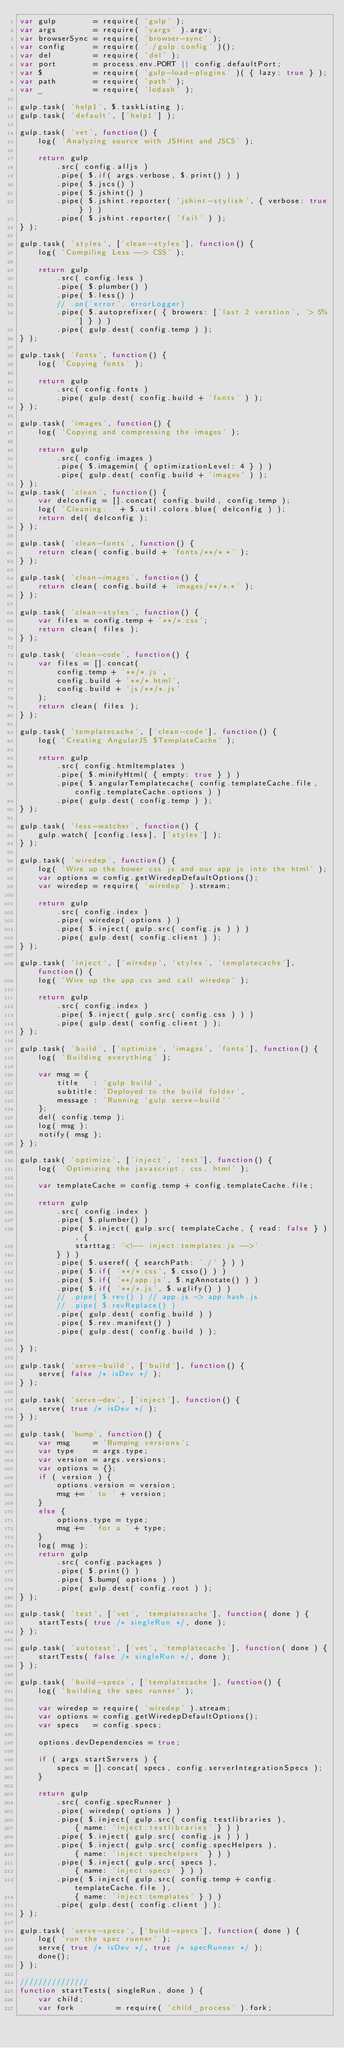<code> <loc_0><loc_0><loc_500><loc_500><_JavaScript_>var gulp        = require( 'gulp' );
var args        = require( 'yargs' ).argv;
var browserSync = require( 'browser-sync' );
var config      = require( './gulp.config' )();
var del         = require( 'del' );
var port        = process.env.PORT || config.defaultPort;
var $           = require( 'gulp-load-plugins' )( { lazy: true } );
var path        = require( 'path' );
var _           = require( 'lodash' );

gulp.task( 'help1', $.taskListing );
gulp.task( 'default', ['help1'] );

gulp.task( 'vet', function() {
    log( 'Analyzing source with JSHint and JSCS' );

    return gulp
        .src( config.alljs )
        .pipe( $.if( args.verbose, $.print() ) )
        .pipe( $.jscs() )
        .pipe( $.jshint() )
        .pipe( $.jshint.reporter( 'jshint-stylish', { verbose: true } ) )
        .pipe( $.jshint.reporter( 'fail' ) );
} );

gulp.task( 'styles', ['clean-styles'], function() {
    log( 'Compiling Less --> CSS' );

    return gulp
        .src( config.less )
        .pipe( $.plumber() )
        .pipe( $.less() )
        // .on('error', errorLogger)
        .pipe( $.autoprefixer( { browers: ['last 2 verstion', '> 5%'] } ) )
        .pipe( gulp.dest( config.temp ) );
} );

gulp.task( 'fonts', function() {
    log( 'Copying fonts' );

    return gulp
        .src( config.fonts )
        .pipe( gulp.dest( config.build + 'fonts' ) );
} );

gulp.task( 'images', function() {
    log( 'Copying and compressing the images' );

    return gulp
        .src( config.images )
        .pipe( $.imagemin( { optimizationLevel: 4 } ) )
        .pipe( gulp.dest( config.build + 'images' ) );
} );
gulp.task( 'clean', function() {
    var delconfig = [].concat( config.build, config.temp );
    log( 'Cleaning: ' + $.util.colors.blue( delconfig ) );
    return del( delconfig );
} );

gulp.task( 'clean-fonts', function() {
    return clean( config.build + 'fonts/**/*.*' );
} );

gulp.task( 'clean-images', function() {
    return clean( config.build + 'images/**/*.*' );
} );

gulp.task( 'clean-styles', function() {
    var files = config.temp + '**/*.css';
    return clean( files );
} );

gulp.task( 'clean-code', function() {
    var files = [].concat(
        config.temp + '**/*.js',
        config.build + '**/*.html',
        config.build + 'js/**/*.js'
    );
    return clean( files );
} );

gulp.task( 'templatecache', ['clean-code'], function() {
    log( 'Creating AngularJS $TemplateCache' );

    return gulp
        .src( config.htmltemplates )
        .pipe( $.minifyHtml( { empty: true } ) )
        .pipe( $.angularTemplatecache( config.templateCache.file, config.templateCache.options ) )
        .pipe( gulp.dest( config.temp ) );
} );

gulp.task( 'less-watcher', function() {
    gulp.watch( [config.less], ['styles'] );
} );

gulp.task( 'wiredep', function() {
    log( 'Wire up the bower css js and our app js into the html' );
    var options = config.getWiredepDefaultOptions();
    var wiredep = require( 'wiredep' ).stream;

    return gulp
        .src( config.index )
        .pipe( wiredep( options ) )
        .pipe( $.inject( gulp.src( config.js ) ) )
        .pipe( gulp.dest( config.client ) );
} );

gulp.task( 'inject', ['wiredep', 'styles', 'templatecache'], function() {
    log( 'Wire up the app css and call wiredep' );

    return gulp
        .src( config.index )
        .pipe( $.inject( gulp.src( config.css ) ) )
        .pipe( gulp.dest( config.client ) );
} );

gulp.task( 'build', ['optimize', 'images', 'fonts'], function() {
    log( 'Building everything' );

    var msg = {
        title   : 'gulp build',
        subtitle: 'Deployed to the build folder',
        message : 'Running `gulp serve-build`'
    };
    del( config.temp );
    log( msg );
    notify( msg );
} );

gulp.task( 'optimize', ['inject', 'test'], function() {
    log( 'Optimizing the javascript, css, html' );

    var templateCache = config.temp + config.templateCache.file;

    return gulp
        .src( config.index )
        .pipe( $.plumber() )
        .pipe( $.inject( gulp.src( templateCache, { read: false } ), {
            starttag: '<!-- inject:templates:js -->'
        } ) )
        .pipe( $.useref( { searchPath: './' } ) )
        .pipe( $.if( '**/*.css', $.csso() ) )
        .pipe( $.if( '**/app.js', $.ngAnnotate() ) )
        .pipe( $.if( '**/*.js', $.uglify() ) )
        // .pipe( $.rev() ) // app.js -> app.hash.js
        // .pipe( $.revReplace() )
        .pipe( gulp.dest( config.build ) )
        .pipe( $.rev.manifest() )
        .pipe( gulp.dest( config.build ) );

} );

gulp.task( 'serve-build', ['build'], function() {
    serve( false /* isDev */ );
} );

gulp.task( 'serve-dev', ['inject'], function() {
    serve( true /* isDev */ );
} );

gulp.task( 'bump', function() {
    var msg     = 'Bumping versions';
    var type    = args.type;
    var version = args.versions;
    var options = {};
    if ( version ) {
        options.version = version;
        msg += ' to ' + version;
    }
    else {
        options.type = type;
        msg += ' for a ' + type;
    }
    log( msg );
    return gulp
        .src( config.packages )
        .pipe( $.print() )
        .pipe( $.bump( options ) )
        .pipe( gulp.dest( config.root ) );
} );

gulp.task( 'test', ['vet', 'templatecache'], function( done ) {
    startTests( true /* singleRun */, done );
} );

gulp.task( 'autotest', ['vet', 'templatecache'], function( done ) {
    startTests( false /* singleRun */, done );
} );

gulp.task( 'build-specs', ['templatecache'], function() {
    log( 'building the spec runner' );

    var wiredep = require( 'wiredep' ).stream;
    var options = config.getWiredepDefaultOptions();
    var specs   = config.specs;

    options.devDependencies = true;

    if ( args.startServers ) {
        specs = [].concat( specs, config.serverIntegrationSpecs );
    }

    return gulp
        .src( config.specRunner )
        .pipe( wiredep( options ) )
        .pipe( $.inject( gulp.src( config.testlibraries ),
            { name: 'inject:testlibraries' } ) )
        .pipe( $.inject( gulp.src( config.js ) ) )
        .pipe( $.inject( gulp.src( config.specHelpers ),
            { name: 'inject:spechelpers' } ) )
        .pipe( $.inject( gulp.src( specs ),
            { name: 'inject:specs' } ) )
        .pipe( $.inject( gulp.src( config.temp + config.templateCache.file ),
            { name: 'inject:templates' } ) )
        .pipe( gulp.dest( config.client ) );
} );

gulp.task( 'serve-specs', ['build-specs'], function( done ) {
    log( 'run the spec runner' );
    serve( true /* isDev */, true /* specRunner */ );
    done();
} );

///////////////
function startTests( singleRun, done ) {
    var child;
    var fork         = require( 'child_process' ).fork;</code> 